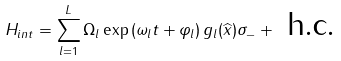<formula> <loc_0><loc_0><loc_500><loc_500>H _ { i n t } = \sum _ { l = 1 } ^ { L } \Omega _ { l } \exp \left ( \omega _ { l } t + \varphi _ { l } \right ) g _ { l } ( \widehat { x } ) \sigma _ { - } + \text { h.c.}</formula> 